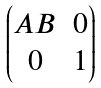<formula> <loc_0><loc_0><loc_500><loc_500>\begin{pmatrix} A B & 0 \\ 0 & 1 \end{pmatrix}</formula> 